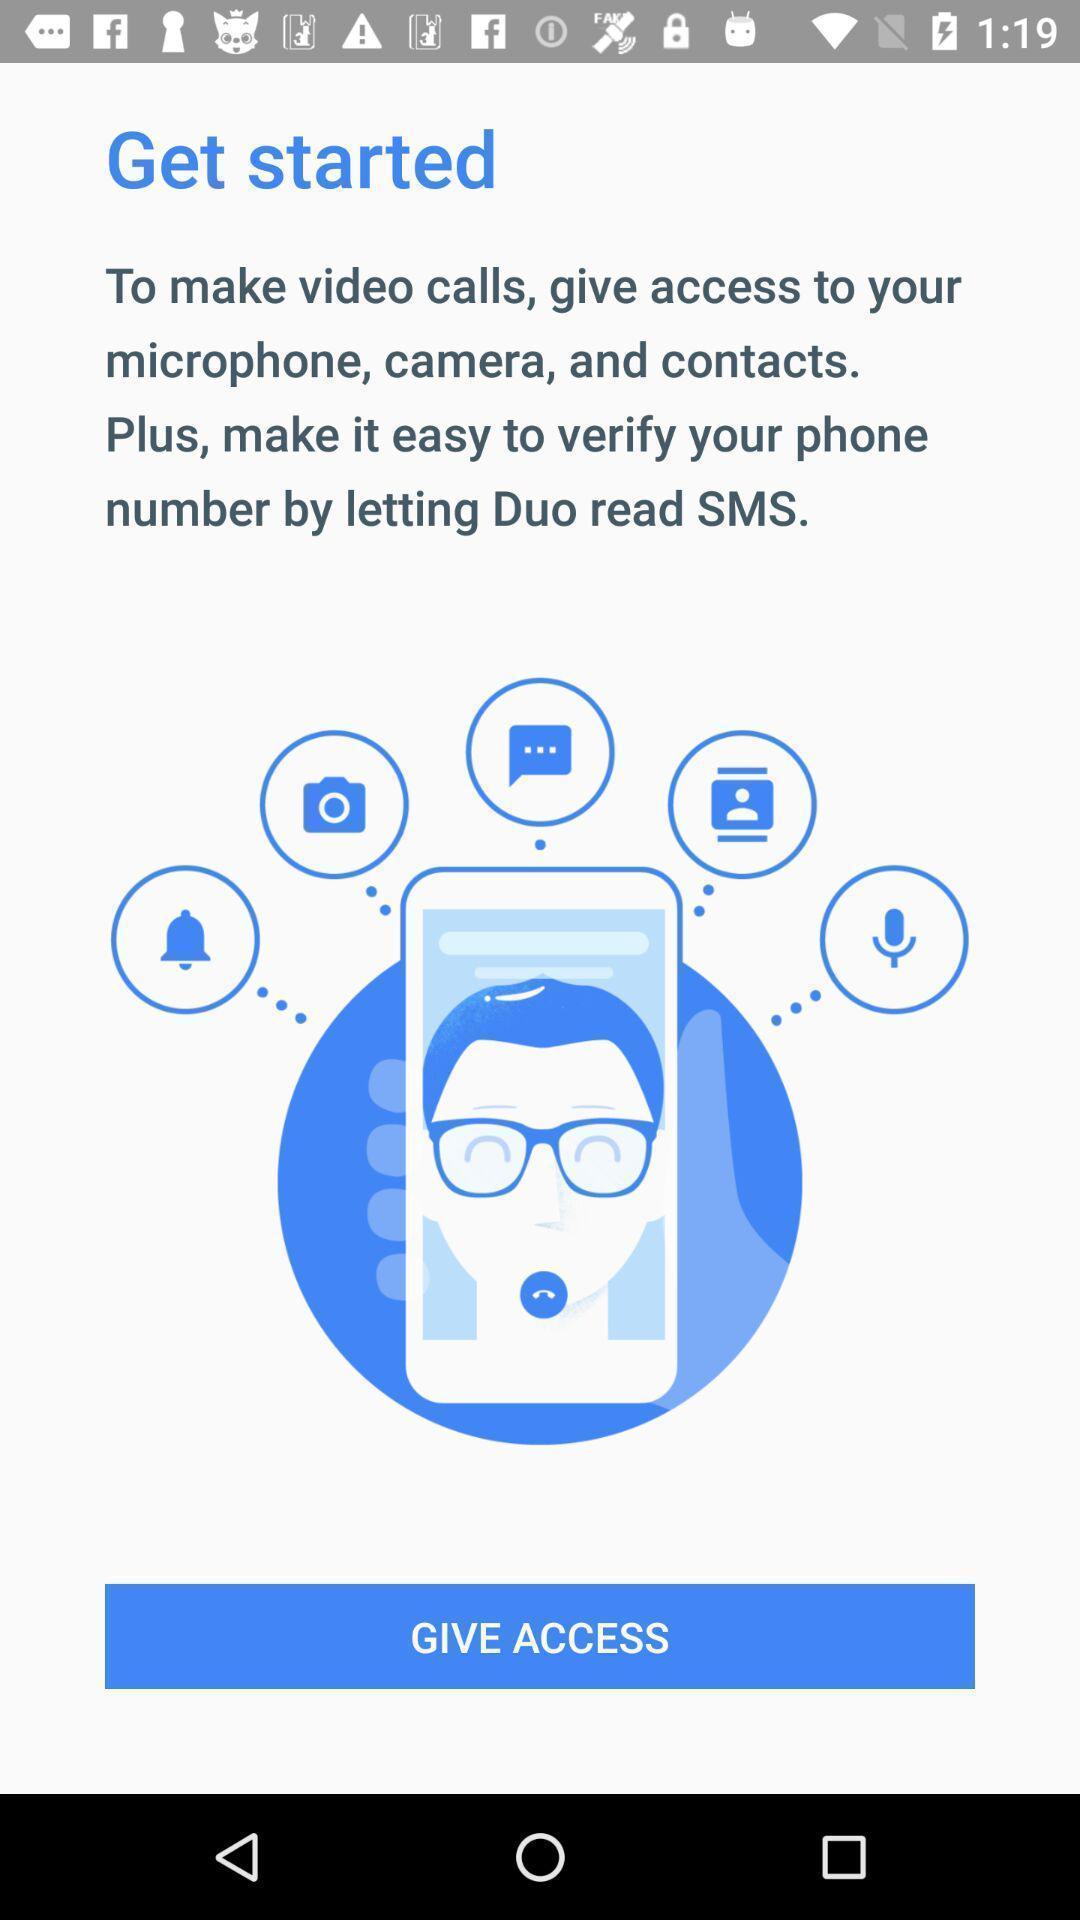Give me a summary of this screen capture. Welcome page for the video calling app. 